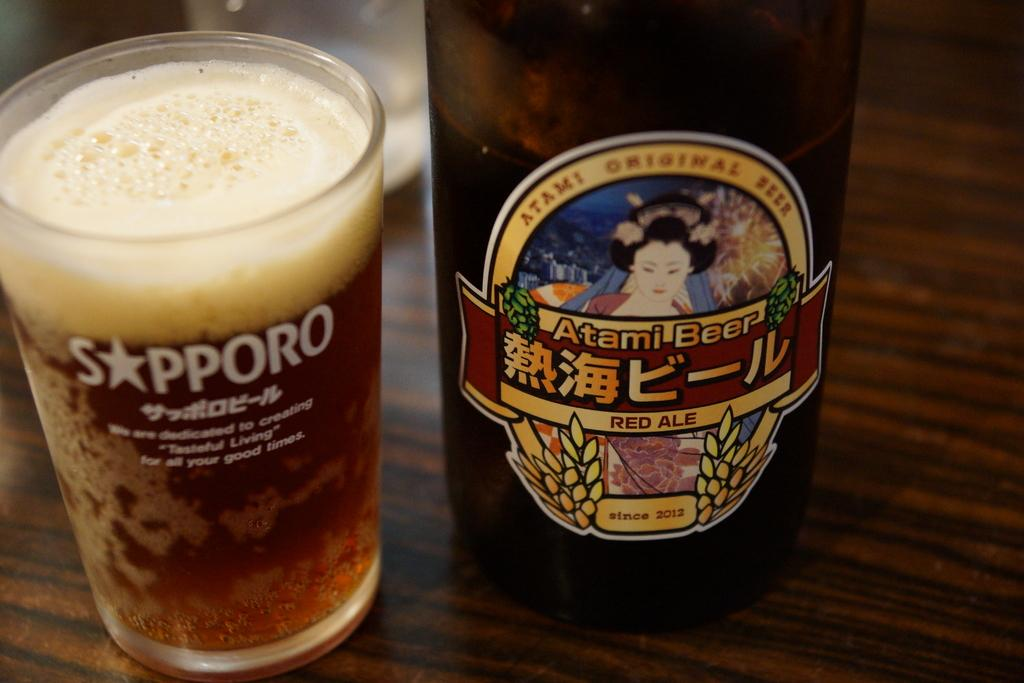<image>
Describe the image concisely. A bottle of Atami Beer sitting next to a full beer glass with Sapporo written on it. 